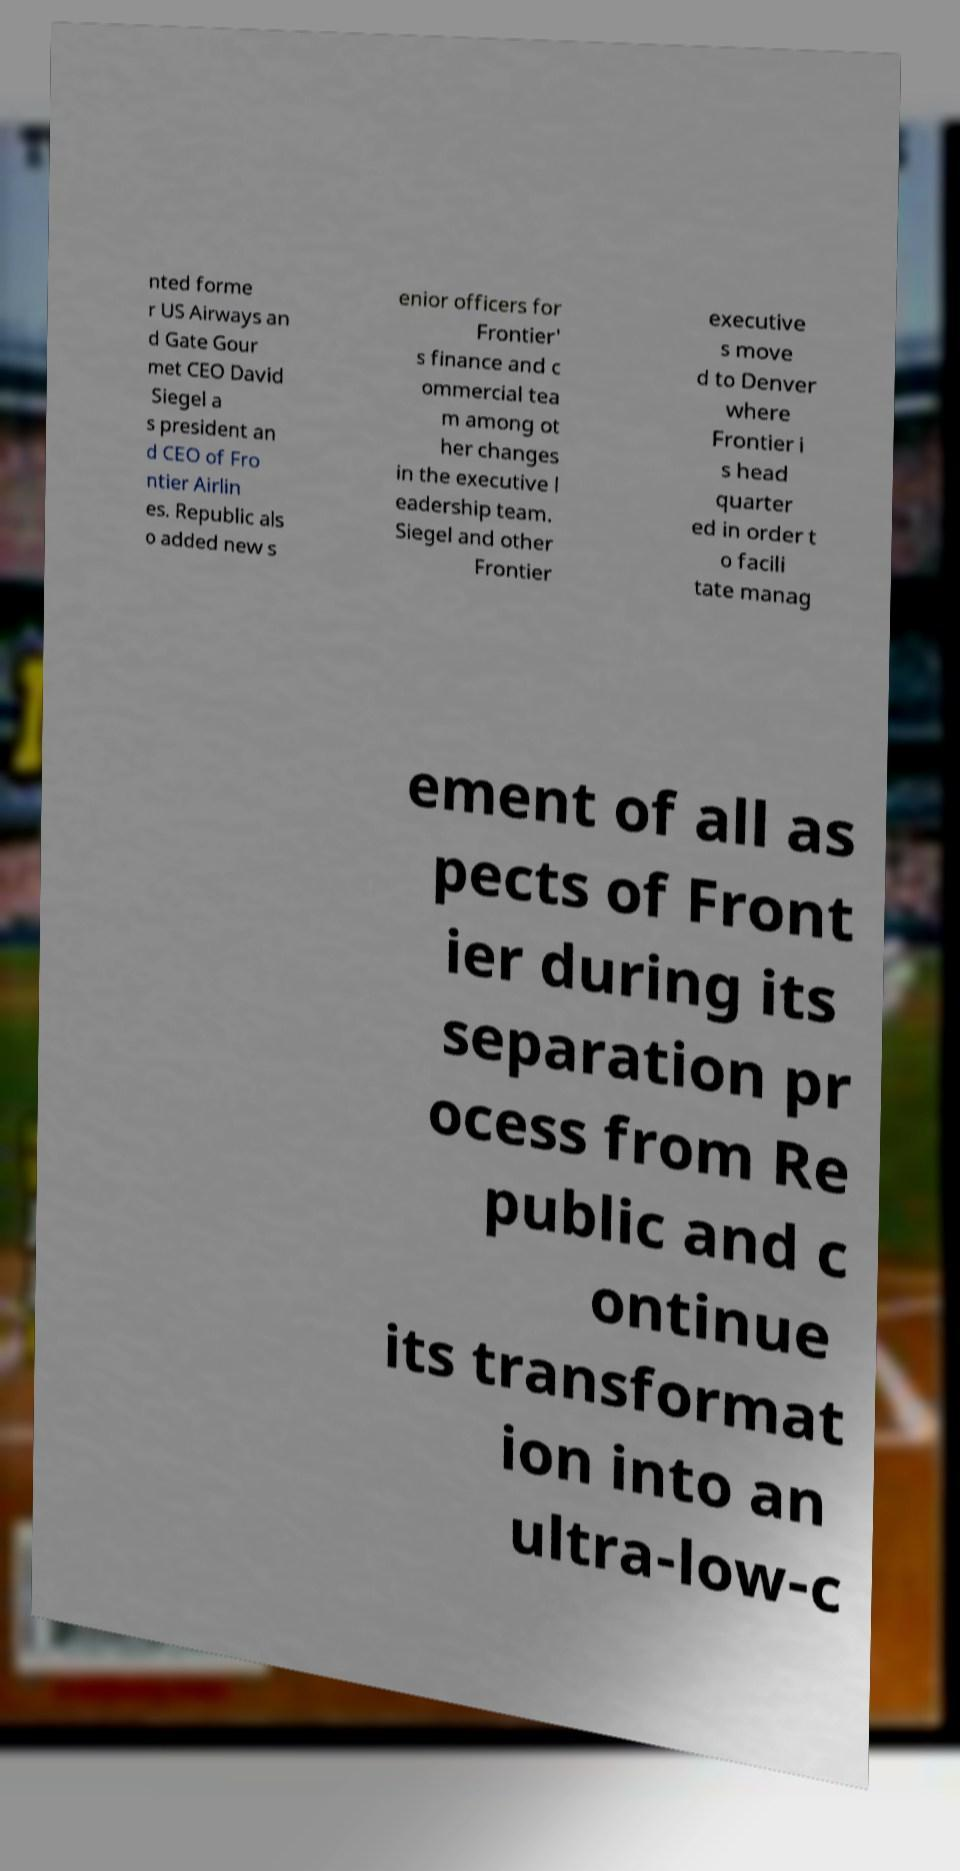There's text embedded in this image that I need extracted. Can you transcribe it verbatim? nted forme r US Airways an d Gate Gour met CEO David Siegel a s president an d CEO of Fro ntier Airlin es. Republic als o added new s enior officers for Frontier' s finance and c ommercial tea m among ot her changes in the executive l eadership team. Siegel and other Frontier executive s move d to Denver where Frontier i s head quarter ed in order t o facili tate manag ement of all as pects of Front ier during its separation pr ocess from Re public and c ontinue its transformat ion into an ultra-low-c 